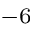Convert formula to latex. <formula><loc_0><loc_0><loc_500><loc_500>^ { - 6 }</formula> 